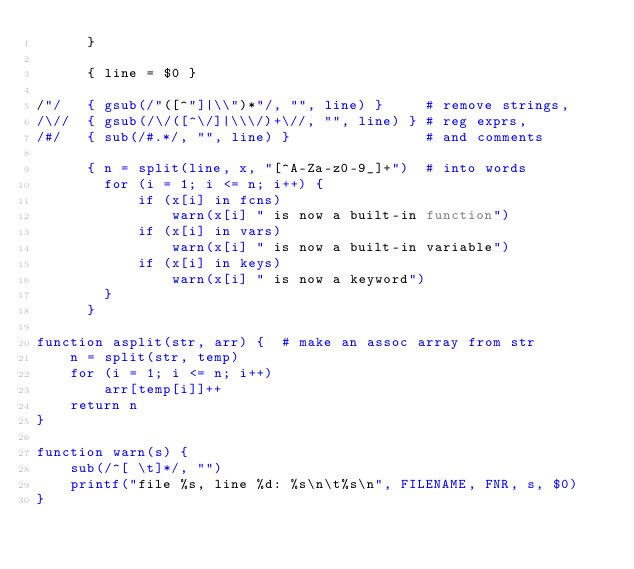<code> <loc_0><loc_0><loc_500><loc_500><_Awk_>      }

      { line = $0 }

/"/   { gsub(/"([^"]|\\")*"/, "", line) }     # remove strings,
/\//  { gsub(/\/([^\/]|\\\/)+\//, "", line) } # reg exprs,
/#/   { sub(/#.*/, "", line) }                # and comments

      { n = split(line, x, "[^A-Za-z0-9_]+")  # into words
        for (i = 1; i <= n; i++) {
            if (x[i] in fcns)	
                warn(x[i] " is now a built-in function")
            if (x[i] in vars)
                warn(x[i] " is now a built-in variable")
            if (x[i] in keys)
                warn(x[i] " is now a keyword")
        }
      }

function asplit(str, arr) {  # make an assoc array from str
    n = split(str, temp)
    for (i = 1; i <= n; i++)
        arr[temp[i]]++
    return n
}

function warn(s) {
    sub(/^[ \t]*/, "")
    printf("file %s, line %d: %s\n\t%s\n", FILENAME, FNR, s, $0)
}
</code> 